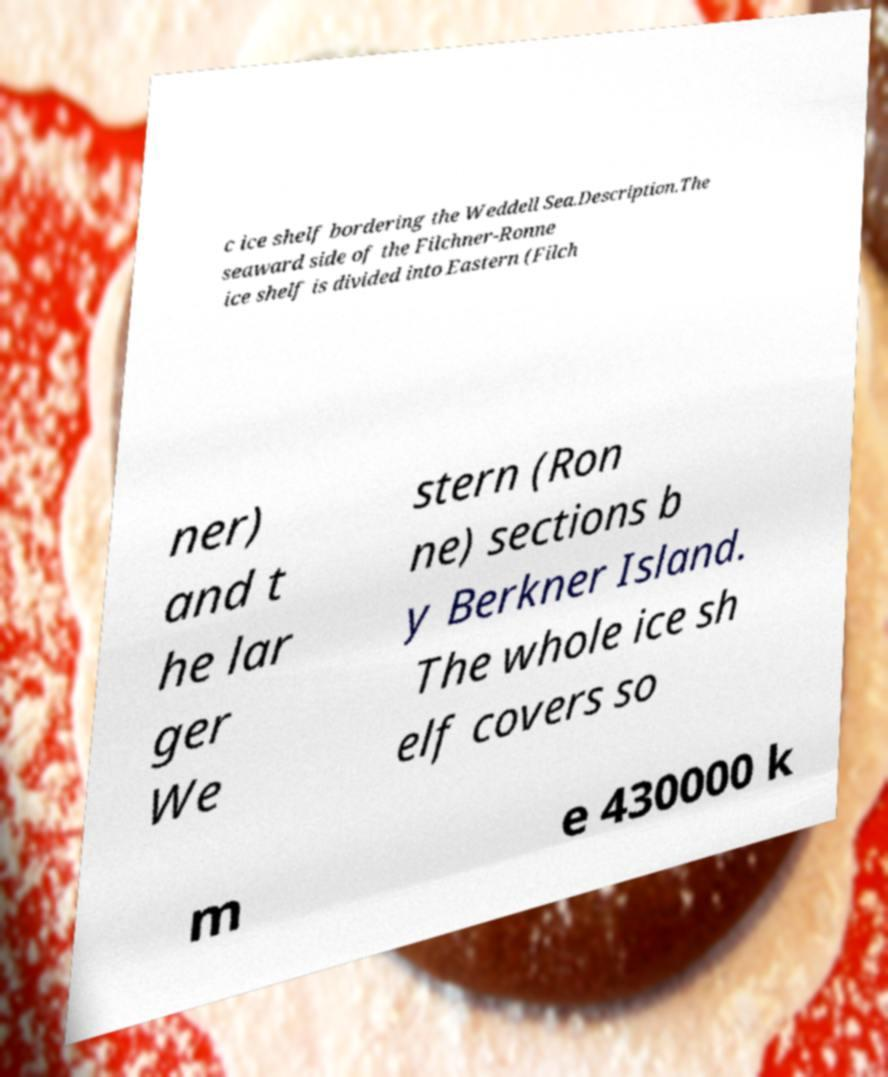For documentation purposes, I need the text within this image transcribed. Could you provide that? c ice shelf bordering the Weddell Sea.Description.The seaward side of the Filchner-Ronne ice shelf is divided into Eastern (Filch ner) and t he lar ger We stern (Ron ne) sections b y Berkner Island. The whole ice sh elf covers so m e 430000 k 